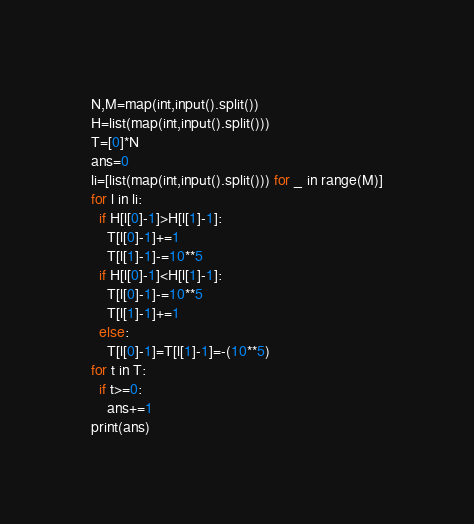Convert code to text. <code><loc_0><loc_0><loc_500><loc_500><_Python_>N,M=map(int,input().split())
H=list(map(int,input().split()))
T=[0]*N
ans=0
li=[list(map(int,input().split())) for _ in range(M)]
for l in li:
  if H[l[0]-1]>H[l[1]-1]:
    T[l[0]-1]+=1
    T[l[1]-1]-=10**5
  if H[l[0]-1]<H[l[1]-1]:
    T[l[0]-1]-=10**5
    T[l[1]-1]+=1
  else:
    T[l[0]-1]=T[l[1]-1]=-(10**5)
for t in T:
  if t>=0:
    ans+=1
print(ans)</code> 